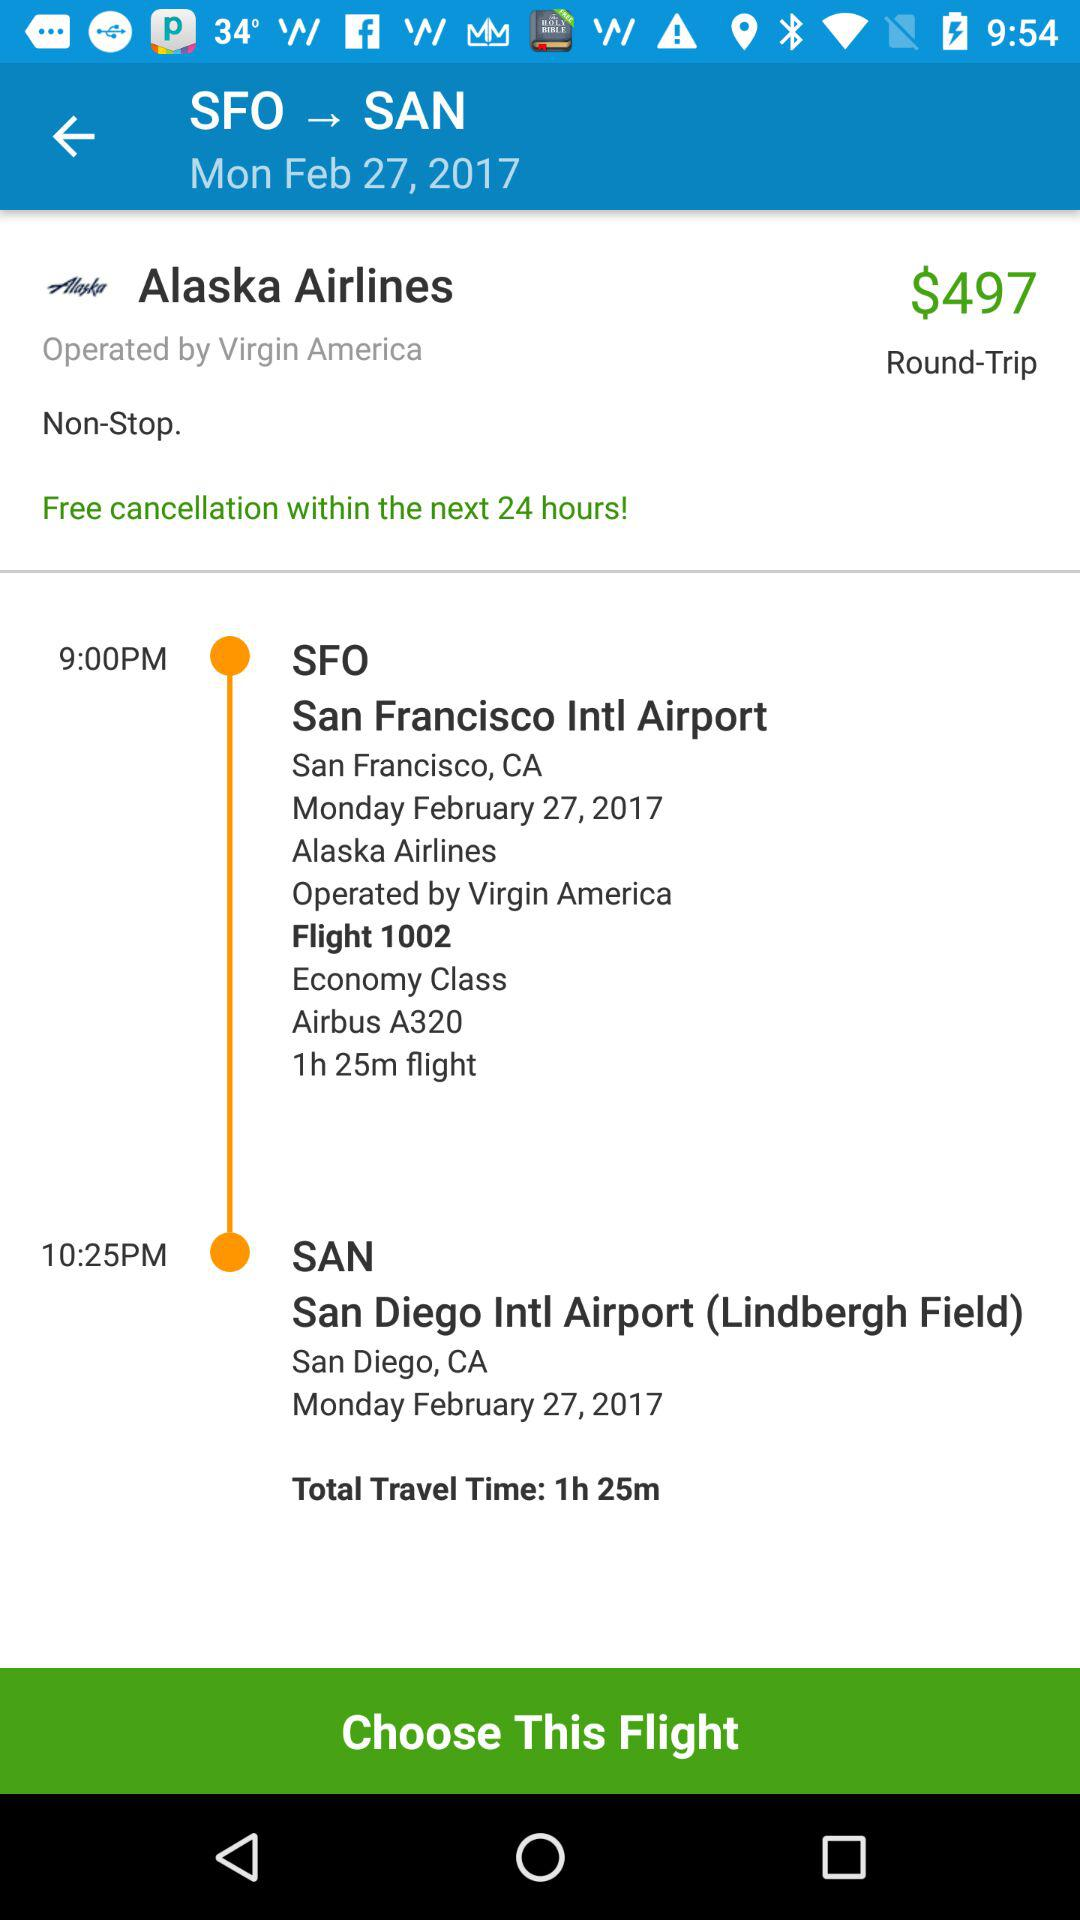What is the flight's departure date and day? The flight's departure date is February 27, 2017 and the day is Monday. 